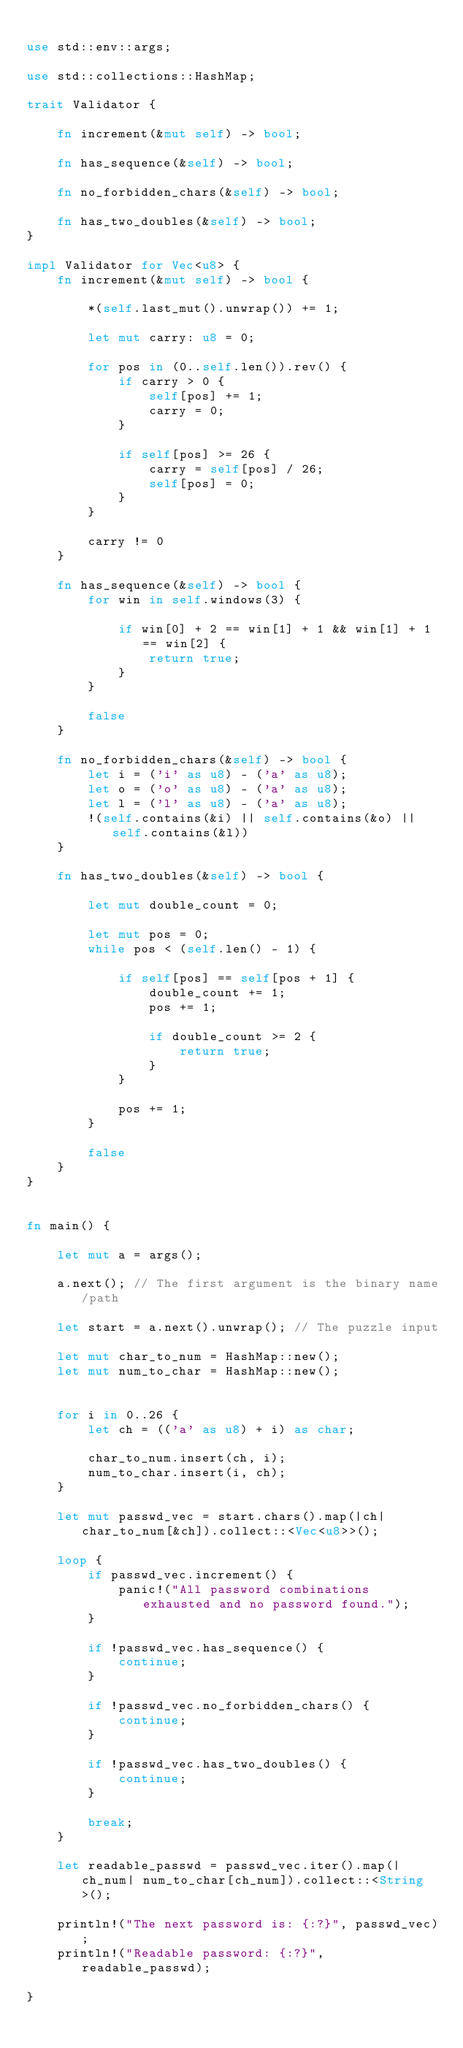Convert code to text. <code><loc_0><loc_0><loc_500><loc_500><_Rust_>
use std::env::args;

use std::collections::HashMap;

trait Validator {

    fn increment(&mut self) -> bool;

    fn has_sequence(&self) -> bool;

    fn no_forbidden_chars(&self) -> bool;

    fn has_two_doubles(&self) -> bool;
}

impl Validator for Vec<u8> {
    fn increment(&mut self) -> bool {

        *(self.last_mut().unwrap()) += 1;

        let mut carry: u8 = 0;

        for pos in (0..self.len()).rev() {
            if carry > 0 {
                self[pos] += 1;
                carry = 0;
            }

            if self[pos] >= 26 {
                carry = self[pos] / 26;
                self[pos] = 0;
            }
        }

        carry != 0
    }

    fn has_sequence(&self) -> bool {
        for win in self.windows(3) {

            if win[0] + 2 == win[1] + 1 && win[1] + 1 == win[2] {
                return true;
            }
        }

        false
    }

    fn no_forbidden_chars(&self) -> bool {
        let i = ('i' as u8) - ('a' as u8);
        let o = ('o' as u8) - ('a' as u8);
        let l = ('l' as u8) - ('a' as u8);
        !(self.contains(&i) || self.contains(&o) || self.contains(&l))
    }

    fn has_two_doubles(&self) -> bool {

        let mut double_count = 0;

        let mut pos = 0;
        while pos < (self.len() - 1) {

            if self[pos] == self[pos + 1] {
                double_count += 1;
                pos += 1;

                if double_count >= 2 {
                    return true;
                }
            }

            pos += 1;
        }

        false
    }
}


fn main() {

    let mut a = args();

    a.next(); // The first argument is the binary name/path

    let start = a.next().unwrap(); // The puzzle input

    let mut char_to_num = HashMap::new();
    let mut num_to_char = HashMap::new();


    for i in 0..26 {
        let ch = (('a' as u8) + i) as char;

        char_to_num.insert(ch, i);
        num_to_char.insert(i, ch);
    }

    let mut passwd_vec = start.chars().map(|ch| char_to_num[&ch]).collect::<Vec<u8>>();

    loop {
        if passwd_vec.increment() {
            panic!("All password combinations exhausted and no password found.");
        }

        if !passwd_vec.has_sequence() {
            continue;
        }

        if !passwd_vec.no_forbidden_chars() {
            continue;
        }

        if !passwd_vec.has_two_doubles() {
            continue;
        }

        break;
    }

    let readable_passwd = passwd_vec.iter().map(|ch_num| num_to_char[ch_num]).collect::<String>();

    println!("The next password is: {:?}", passwd_vec);
    println!("Readable password: {:?}", readable_passwd);

}
</code> 